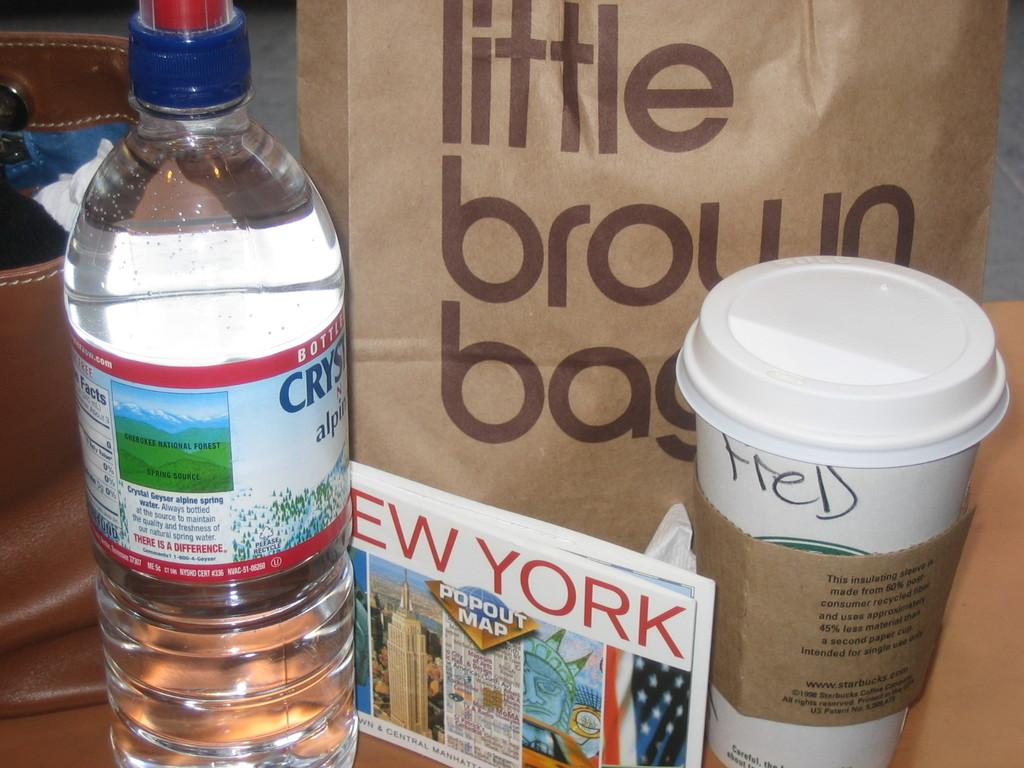<image>
Describe the image concisely. A bottle of water, a New York postcard and a cup pf coffee sit in front of a little brown bag. 